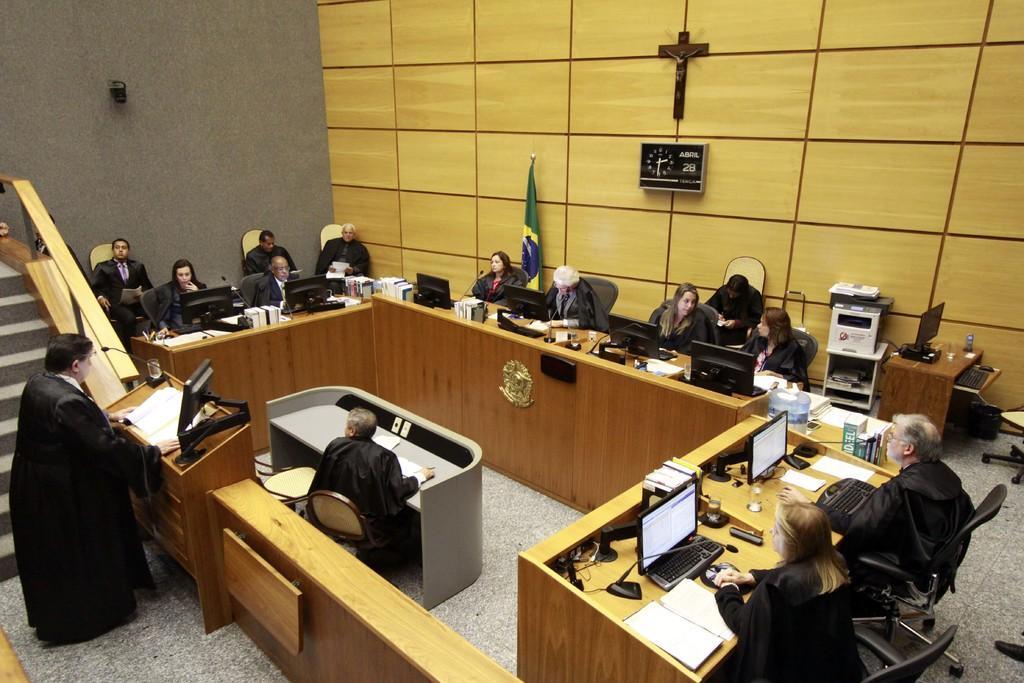Could you give a brief overview of what you see in this image? There are few people sitting on the chairs. This is the desk with monitors,books,and some other objects on it. I can see a kind of podium with a book and a computer here. Here is a man standing and talking on the mike. I can see a flag hanging. This is the clock attached to the wall. Here are some electronic devices. This is the another table with papers on it. 